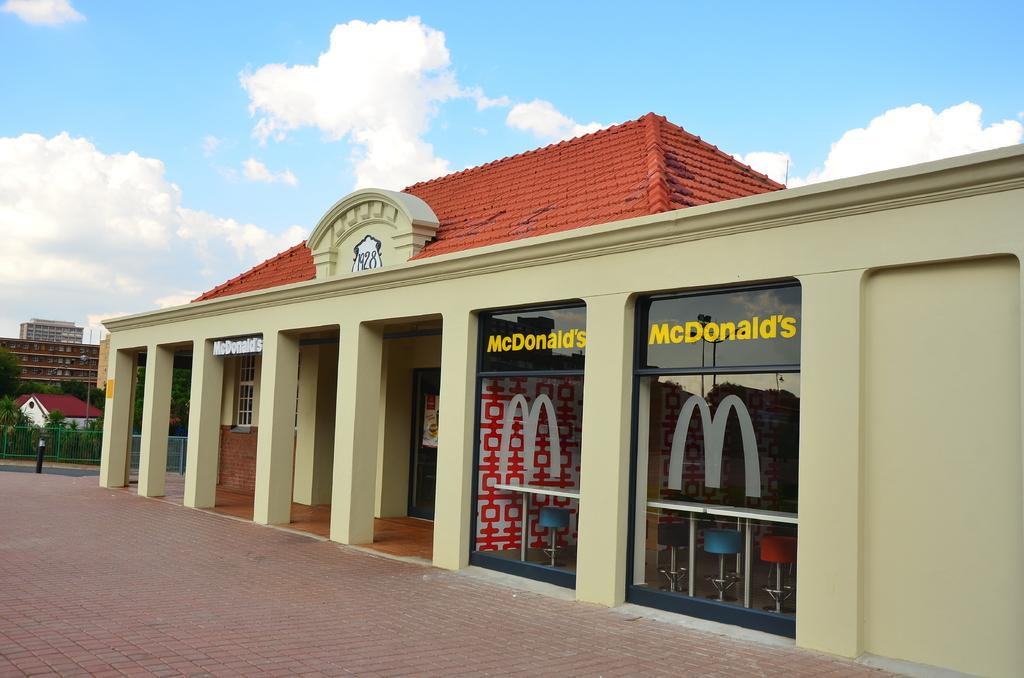<image>
Share a concise interpretation of the image provided. The outside of a McDonald's with a sign saying 1928 